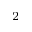Convert formula to latex. <formula><loc_0><loc_0><loc_500><loc_500>^ { 2 }</formula> 